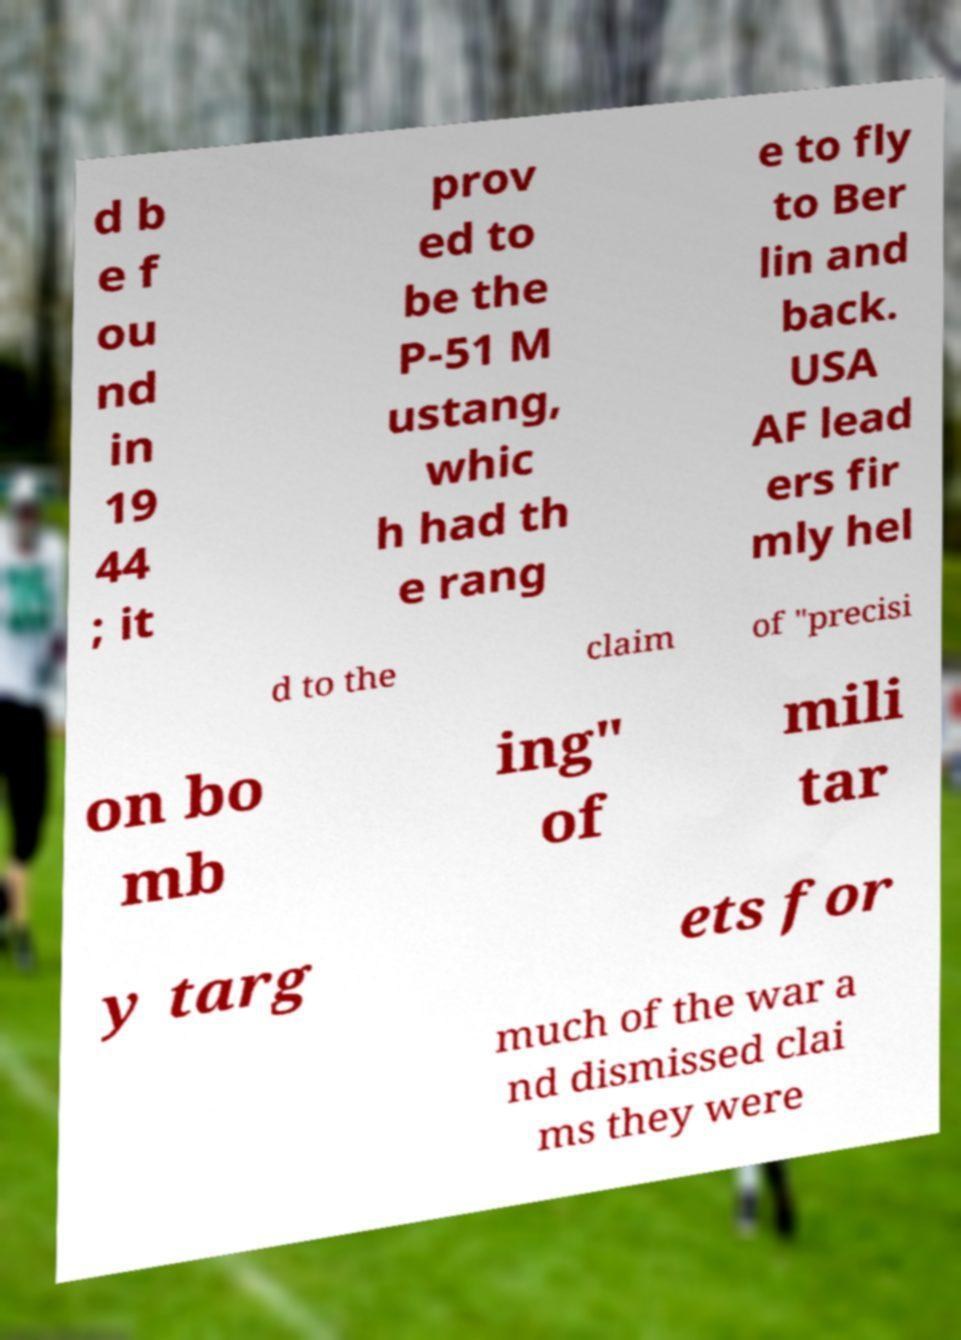Can you read and provide the text displayed in the image?This photo seems to have some interesting text. Can you extract and type it out for me? d b e f ou nd in 19 44 ; it prov ed to be the P-51 M ustang, whic h had th e rang e to fly to Ber lin and back. USA AF lead ers fir mly hel d to the claim of "precisi on bo mb ing" of mili tar y targ ets for much of the war a nd dismissed clai ms they were 